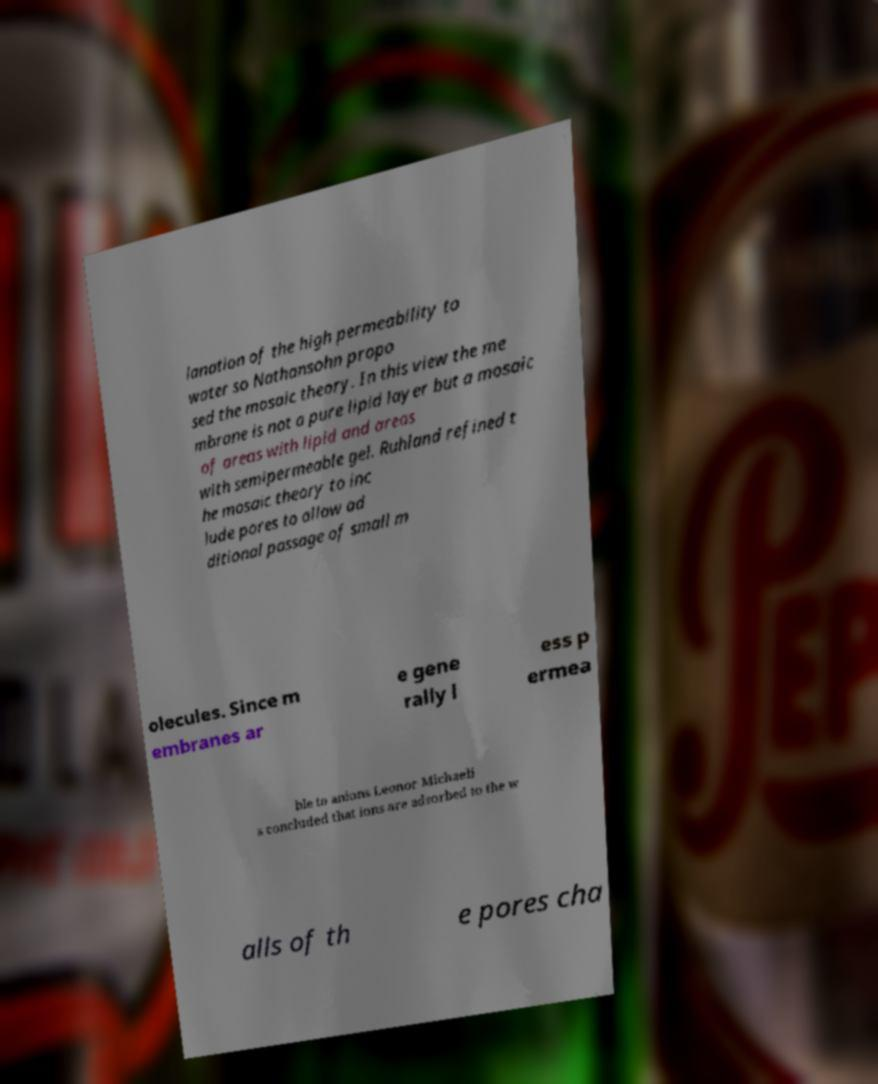Could you assist in decoding the text presented in this image and type it out clearly? lanation of the high permeability to water so Nathansohn propo sed the mosaic theory. In this view the me mbrane is not a pure lipid layer but a mosaic of areas with lipid and areas with semipermeable gel. Ruhland refined t he mosaic theory to inc lude pores to allow ad ditional passage of small m olecules. Since m embranes ar e gene rally l ess p ermea ble to anions Leonor Michaeli s concluded that ions are adsorbed to the w alls of th e pores cha 